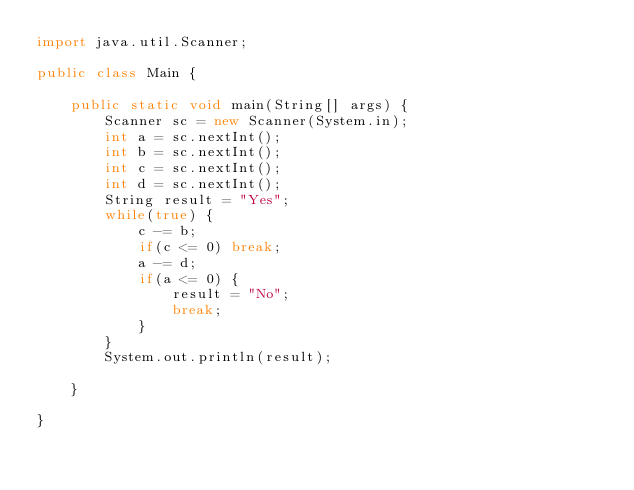Convert code to text. <code><loc_0><loc_0><loc_500><loc_500><_Java_>import java.util.Scanner;

public class Main {

	public static void main(String[] args) {
		Scanner sc = new Scanner(System.in);
		int a = sc.nextInt();
		int b = sc.nextInt();
		int c = sc.nextInt();
		int d = sc.nextInt();
		String result = "Yes";
		while(true) {
			c -= b;
			if(c <= 0) break;
			a -= d;
			if(a <= 0) {
				result = "No";
				break;
			}
		}
		System.out.println(result);

	}

}</code> 